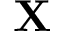<formula> <loc_0><loc_0><loc_500><loc_500>X</formula> 